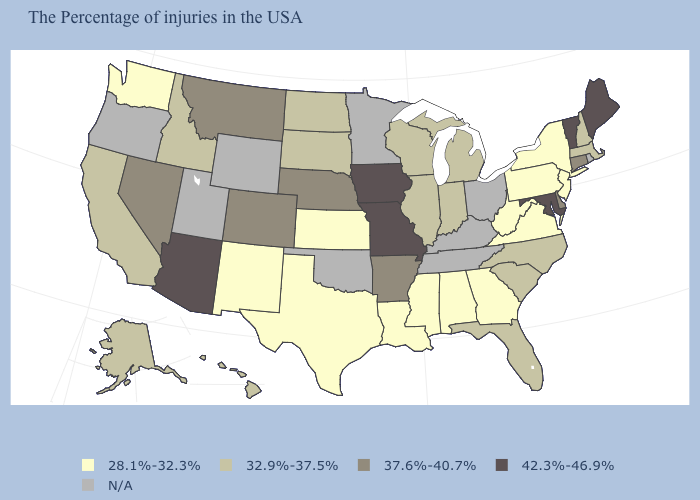Does Texas have the lowest value in the South?
Keep it brief. Yes. Among the states that border New York , which have the lowest value?
Quick response, please. New Jersey, Pennsylvania. Is the legend a continuous bar?
Concise answer only. No. Does the first symbol in the legend represent the smallest category?
Concise answer only. Yes. What is the value of Delaware?
Write a very short answer. 37.6%-40.7%. What is the value of Oregon?
Concise answer only. N/A. Name the states that have a value in the range 28.1%-32.3%?
Be succinct. New York, New Jersey, Pennsylvania, Virginia, West Virginia, Georgia, Alabama, Mississippi, Louisiana, Kansas, Texas, New Mexico, Washington. What is the highest value in the Northeast ?
Be succinct. 42.3%-46.9%. Among the states that border Louisiana , which have the lowest value?
Short answer required. Mississippi, Texas. What is the highest value in the West ?
Quick response, please. 42.3%-46.9%. Among the states that border Alabama , which have the highest value?
Write a very short answer. Florida. Name the states that have a value in the range 28.1%-32.3%?
Short answer required. New York, New Jersey, Pennsylvania, Virginia, West Virginia, Georgia, Alabama, Mississippi, Louisiana, Kansas, Texas, New Mexico, Washington. What is the value of Maine?
Write a very short answer. 42.3%-46.9%. What is the value of Vermont?
Answer briefly. 42.3%-46.9%. Among the states that border Alabama , does Georgia have the highest value?
Write a very short answer. No. 